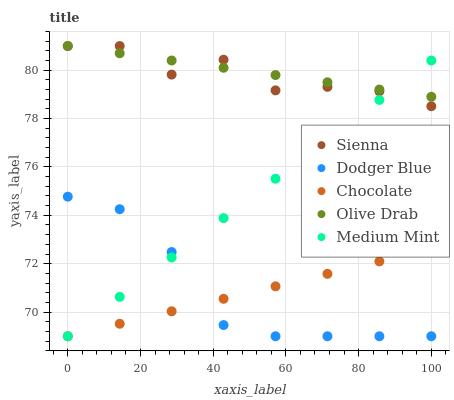Does Dodger Blue have the minimum area under the curve?
Answer yes or no. Yes. Does Olive Drab have the maximum area under the curve?
Answer yes or no. Yes. Does Medium Mint have the minimum area under the curve?
Answer yes or no. No. Does Medium Mint have the maximum area under the curve?
Answer yes or no. No. Is Chocolate the smoothest?
Answer yes or no. Yes. Is Sienna the roughest?
Answer yes or no. Yes. Is Medium Mint the smoothest?
Answer yes or no. No. Is Medium Mint the roughest?
Answer yes or no. No. Does Medium Mint have the lowest value?
Answer yes or no. Yes. Does Olive Drab have the lowest value?
Answer yes or no. No. Does Olive Drab have the highest value?
Answer yes or no. Yes. Does Medium Mint have the highest value?
Answer yes or no. No. Is Dodger Blue less than Sienna?
Answer yes or no. Yes. Is Sienna greater than Chocolate?
Answer yes or no. Yes. Does Sienna intersect Olive Drab?
Answer yes or no. Yes. Is Sienna less than Olive Drab?
Answer yes or no. No. Is Sienna greater than Olive Drab?
Answer yes or no. No. Does Dodger Blue intersect Sienna?
Answer yes or no. No. 